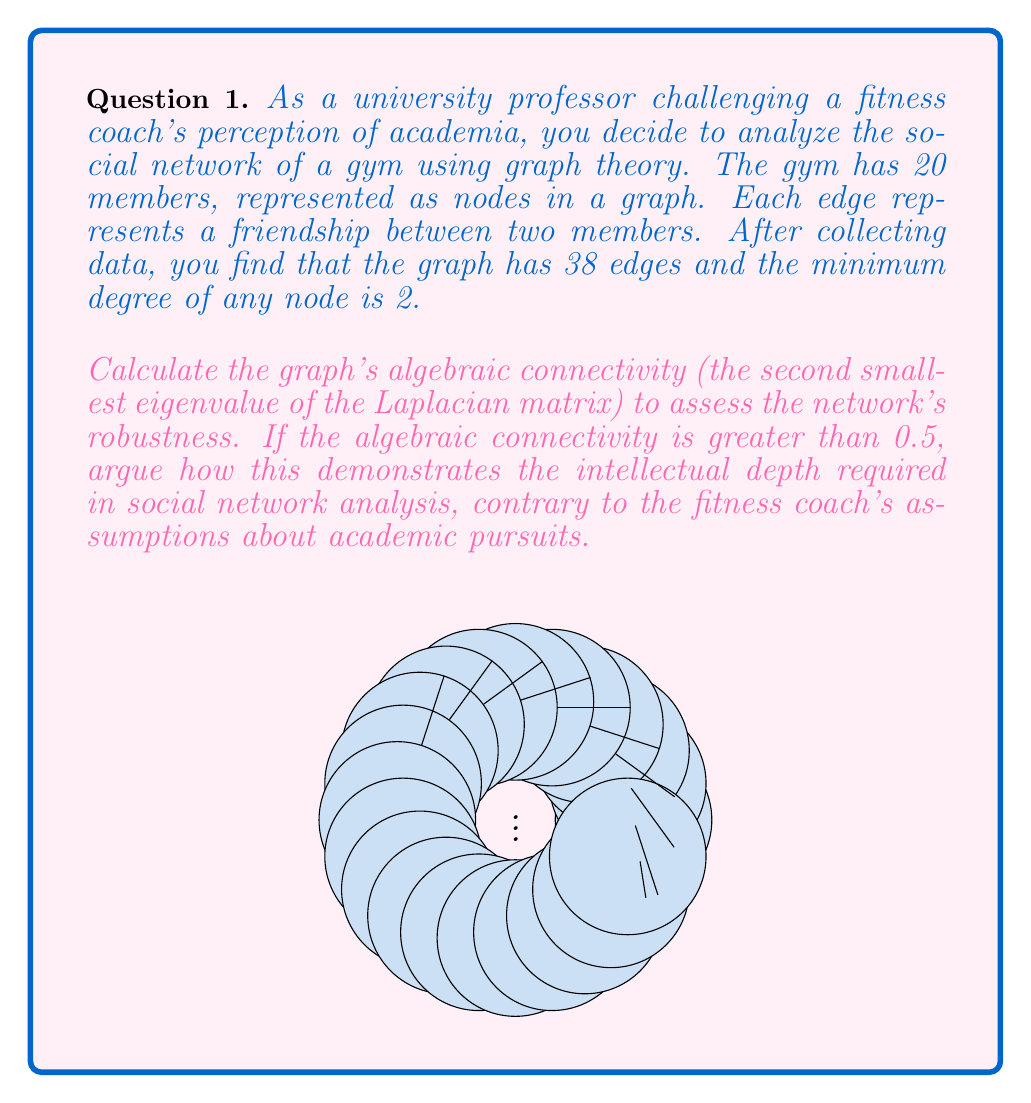Can you answer this question? To solve this problem, we'll follow these steps:

1) First, let's recall the definition of the Laplacian matrix $L$ for an undirected graph:
   $L = D - A$, where $D$ is the degree matrix and $A$ is the adjacency matrix.

2) We need to construct the Laplacian matrix. For a graph with $n$ vertices:
   $$L_{ij} = \begin{cases} 
   d_i & \text{if } i = j \\
   -1 & \text{if } i \neq j \text{ and vertex } i \text{ is adjacent to vertex } j \\
   0 & \text{otherwise}
   \end{cases}$$
   where $d_i$ is the degree of vertex $i$.

3) We're given that the graph has 20 nodes and 38 edges. The minimum degree is 2.

4) To construct the full Laplacian matrix, we'd need to know the exact connections. However, we can make some observations:
   - The sum of all degrees must be twice the number of edges: $\sum d_i = 2|E| = 2(38) = 76$
   - The average degree is $76/20 = 3.8$

5) The Laplacian matrix will be a 20x20 matrix. Its eigenvalues $\lambda_1 \leq \lambda_2 \leq ... \leq \lambda_n$ have some important properties:
   - $\lambda_1 = 0$ always
   - $\lambda_2$ is the algebraic connectivity we're looking for
   - $\lambda_n \leq n$ for a graph with $n$ vertices

6) Without the exact graph structure, we can't calculate the precise value of $\lambda_2$. However, we can estimate its range:
   - For a connected graph, $\lambda_2 > 0$
   - $\lambda_2 \leq \frac{n}{n-1}\delta$, where $\delta$ is the minimum degree
   
   So, $0 < \lambda_2 \leq \frac{20}{19}(2) \approx 2.11$

7) The question states that if $\lambda_2 > 0.5$, we should argue how this demonstrates intellectual depth in social network analysis.

8) Indeed, $\lambda_2 > 0.5$ would indicate:
   - The graph is well-connected (not easily disconnected)
   - Information or influence can spread relatively quickly through the network
   - The network has good expansion properties

9) This analysis requires understanding of linear algebra, spectral graph theory, and network science - demonstrating the intellectual rigor involved in social network analysis.
Answer: $0 < \lambda_2 \leq 2.11$; if $\lambda_2 > 0.5$, it indicates a well-connected, robust network, demonstrating the complexity of social network analysis. 